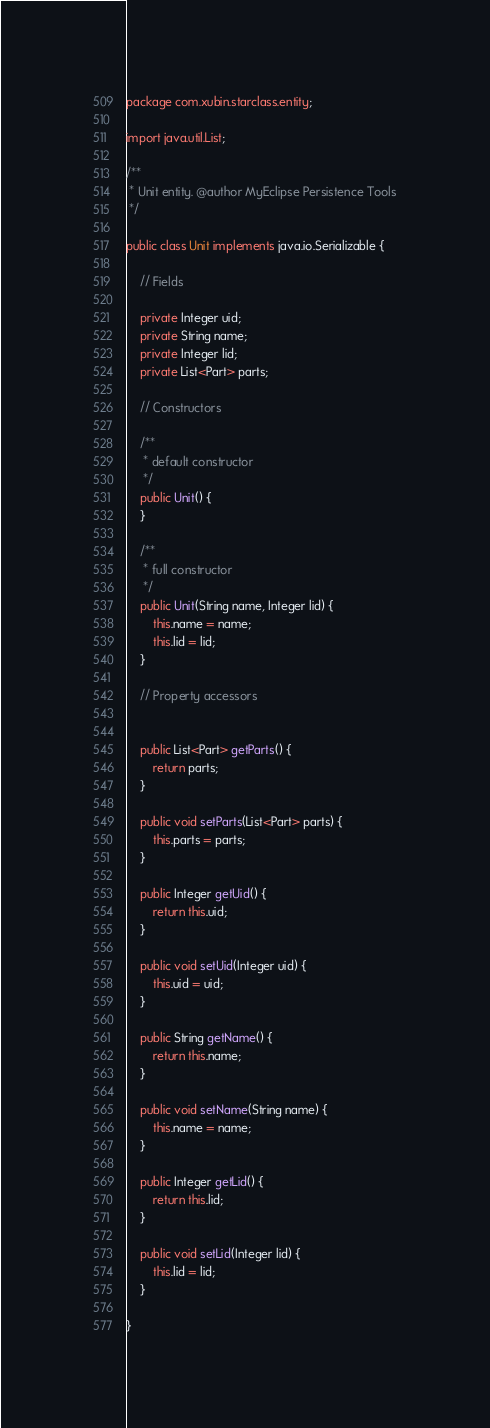Convert code to text. <code><loc_0><loc_0><loc_500><loc_500><_Java_>package com.xubin.starclass.entity;

import java.util.List;

/**
 * Unit entity. @author MyEclipse Persistence Tools
 */

public class Unit implements java.io.Serializable {

    // Fields

    private Integer uid;
    private String name;
    private Integer lid;
    private List<Part> parts;

    // Constructors

    /**
     * default constructor
     */
    public Unit() {
    }

    /**
     * full constructor
     */
    public Unit(String name, Integer lid) {
        this.name = name;
        this.lid = lid;
    }

    // Property accessors


    public List<Part> getParts() {
        return parts;
    }

    public void setParts(List<Part> parts) {
        this.parts = parts;
    }

    public Integer getUid() {
        return this.uid;
    }

    public void setUid(Integer uid) {
        this.uid = uid;
    }

    public String getName() {
        return this.name;
    }

    public void setName(String name) {
        this.name = name;
    }

    public Integer getLid() {
        return this.lid;
    }

    public void setLid(Integer lid) {
        this.lid = lid;
    }

}</code> 